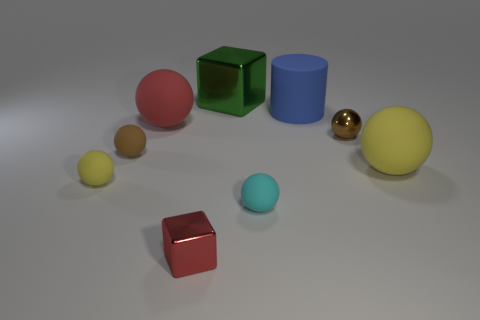Subtract 2 balls. How many balls are left? 4 Subtract all red balls. How many balls are left? 5 Subtract all large yellow rubber spheres. How many spheres are left? 5 Subtract all cyan balls. Subtract all gray cubes. How many balls are left? 5 Subtract all cubes. How many objects are left? 7 Subtract 0 purple cubes. How many objects are left? 9 Subtract all tiny yellow balls. Subtract all large matte balls. How many objects are left? 6 Add 3 big yellow matte things. How many big yellow matte things are left? 4 Add 6 big yellow rubber balls. How many big yellow rubber balls exist? 7 